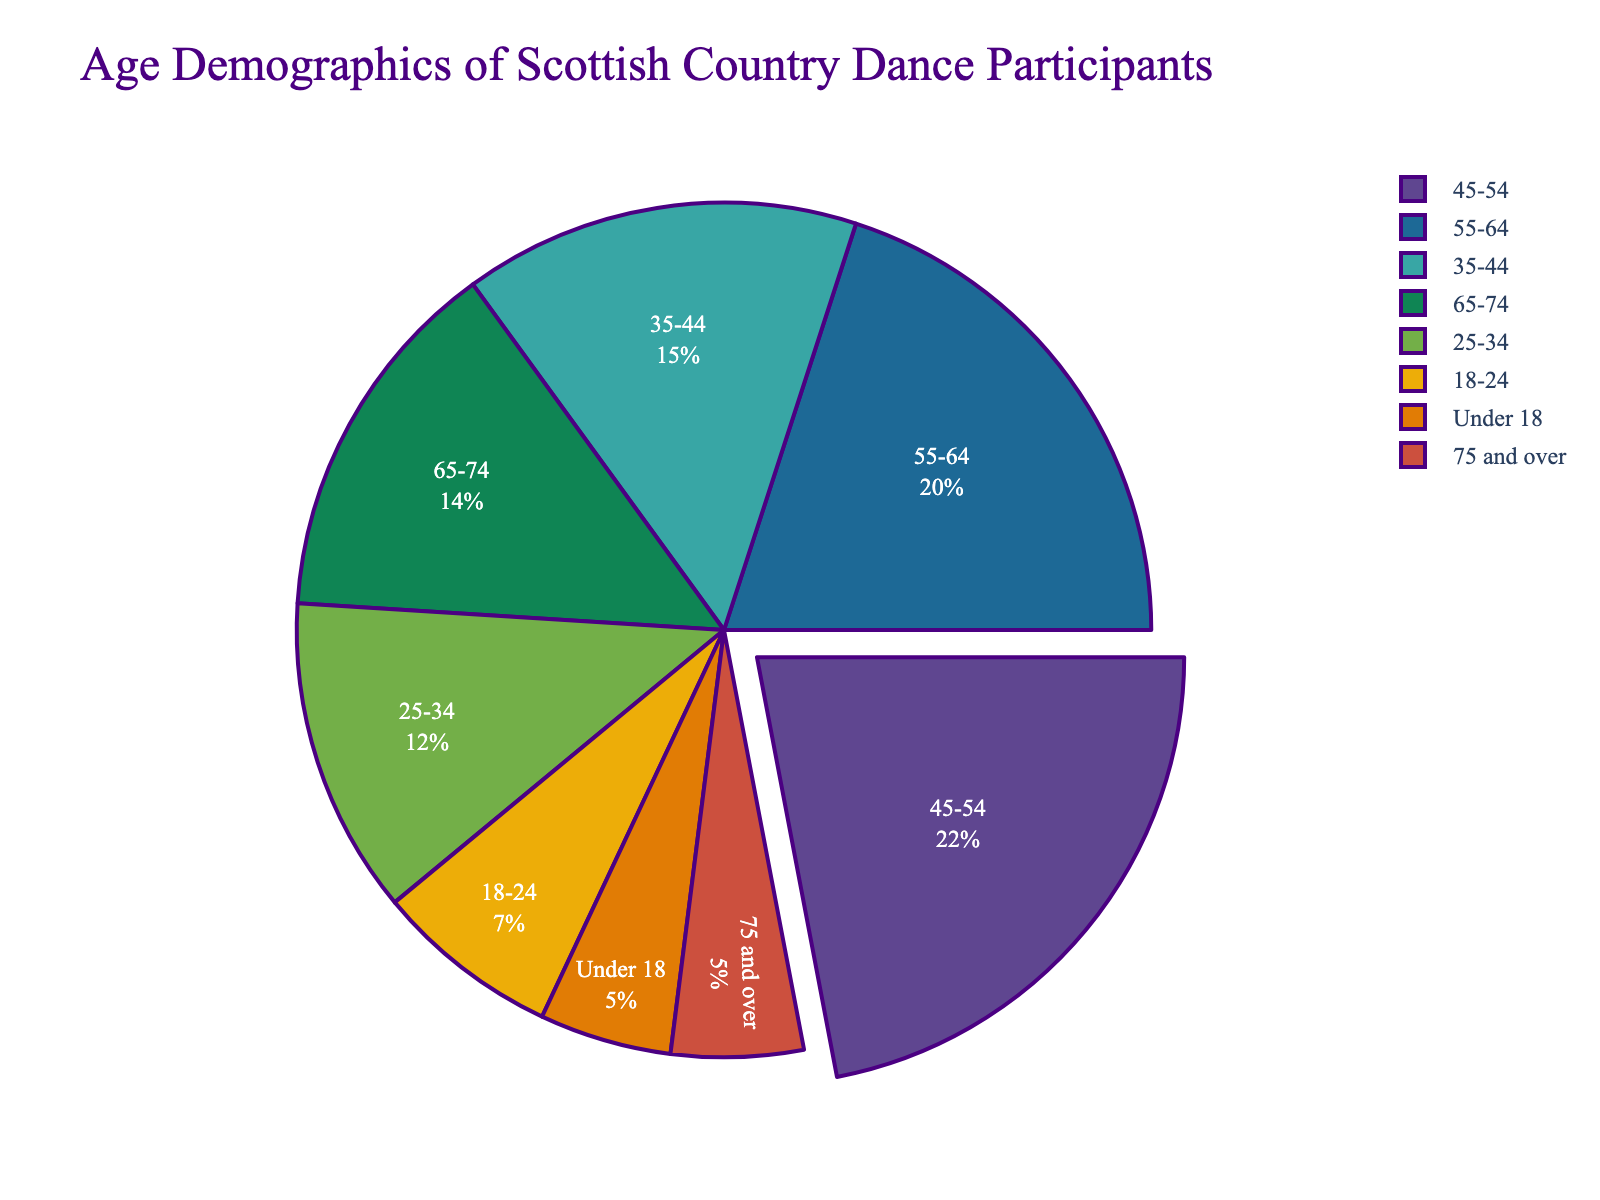What age group has the highest percentage of participants in Scottish Country Dance? The pie chart shows that the age group 45-54 has the highest percentage at 22%.
Answer: 45-54 What is the combined percentage of participants aged under 18 and those aged 75 and over? Summing the percentages of the two groups: 5% (under 18) + 5% (75 and over) = 10%.
Answer: 10% How does the percentage of participants aged 55-64 compare to those aged 25-34? The percentage of participants aged 55-64 is 20%, which is 8 percentage points higher than the 12% of participants aged 25-34.
Answer: 8 percentage points higher Which two age groups have the same percentage of participants, and what is that percentage? The pie chart shows that the age groups Under 18 and 75 and over both have 5% of participants.
Answer: Under 18 and 75 and over, 5% What is the total percentage of participants aged 18-24 and 25-34? Adding the percentages of the two groups: 7% (18-24) + 12% (25-34) = 19%.
Answer: 19% What percentage of participants are aged between 35 and 54? Summing the percentages of the age groups 35-44 and 45-54: 15% (35-44) + 22% (45-54) = 37%.
Answer: 37% Which age group has the lowest percentage of participants, excluding the age groups with 5%? Excluding the age groups with 5%, the next lowest percentage is 7% for the age group 18-24.
Answer: 18-24 What percentage of participants are aged 65 and above? Combining the percentages of 65-74 and 75 and over: 14% (65-74) + 5% (75 and over) = 19%.
Answer: 19% If you combine the age groups 25-34, 35-44, and 45-54, what percentage does this represent? Adding the percentages of the three age groups: 12% (25-34) + 15% (35-44) + 22% (45-54) = 49%.
Answer: 49% 